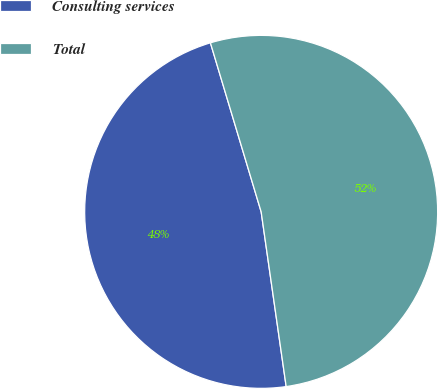Convert chart. <chart><loc_0><loc_0><loc_500><loc_500><pie_chart><fcel>Consulting services<fcel>Total<nl><fcel>47.62%<fcel>52.38%<nl></chart> 